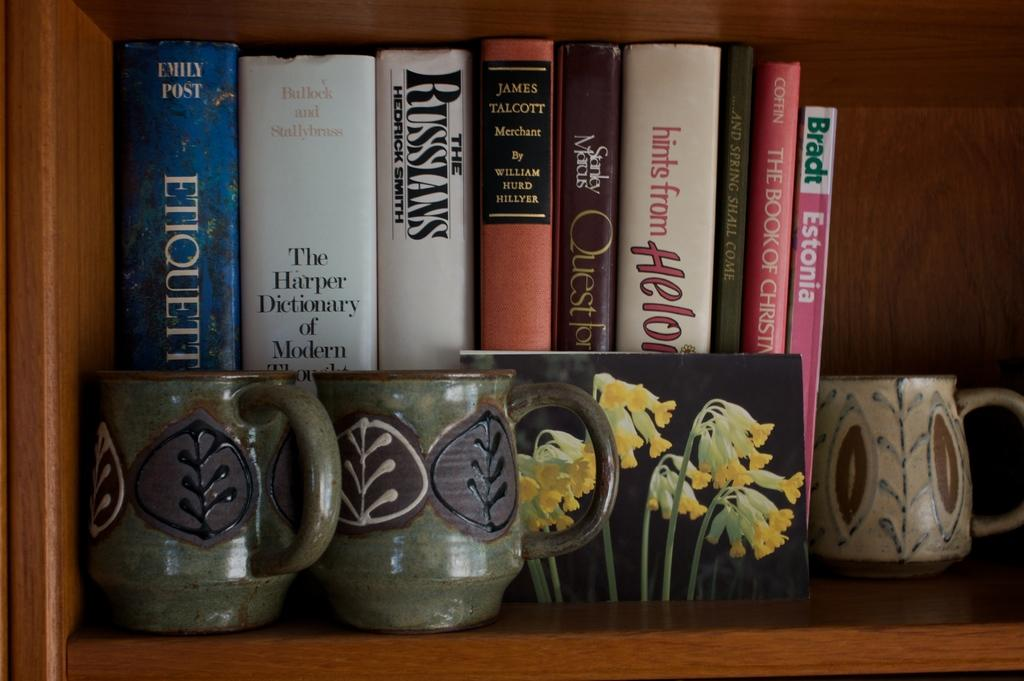What type of objects are stored in the wooden rack in the image? There are books and cups in the wooden rack in the image. Can you describe the material of the rack? The rack is made of wood. What star can be seen shining brightly in the image? There is no star visible in the image; it features a wooden rack with books and cups. What effect does the star have on the objects in the image? There is no star present in the image, so it cannot have any effect on the objects. 